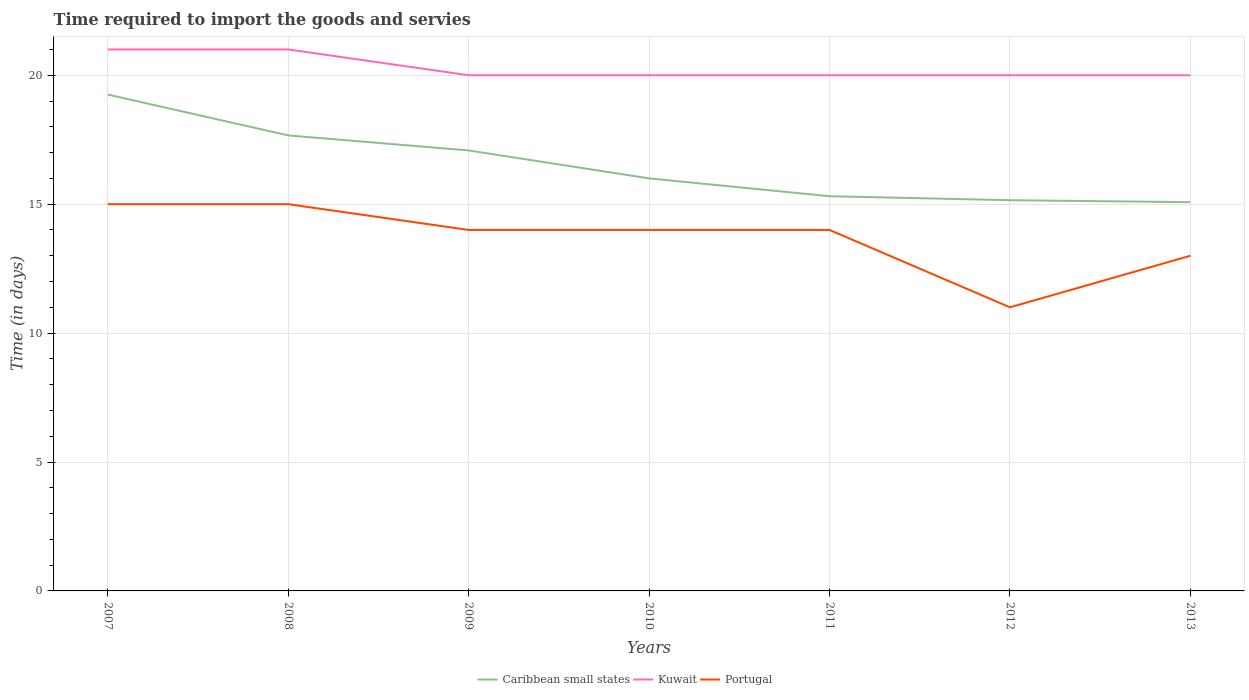How many different coloured lines are there?
Your answer should be very brief. 3. Does the line corresponding to Kuwait intersect with the line corresponding to Caribbean small states?
Offer a terse response. No. Is the number of lines equal to the number of legend labels?
Ensure brevity in your answer.  Yes. Across all years, what is the maximum number of days required to import the goods and services in Caribbean small states?
Ensure brevity in your answer.  15.08. What is the total number of days required to import the goods and services in Caribbean small states in the graph?
Provide a short and direct response. 4.17. What is the difference between the highest and the second highest number of days required to import the goods and services in Caribbean small states?
Give a very brief answer. 4.17. What is the difference between the highest and the lowest number of days required to import the goods and services in Portugal?
Your answer should be very brief. 5. How many lines are there?
Keep it short and to the point. 3. How many years are there in the graph?
Your answer should be compact. 7. Are the values on the major ticks of Y-axis written in scientific E-notation?
Provide a succinct answer. No. What is the title of the graph?
Your response must be concise. Time required to import the goods and servies. What is the label or title of the Y-axis?
Offer a very short reply. Time (in days). What is the Time (in days) in Caribbean small states in 2007?
Your answer should be very brief. 19.25. What is the Time (in days) of Portugal in 2007?
Offer a terse response. 15. What is the Time (in days) of Caribbean small states in 2008?
Offer a very short reply. 17.67. What is the Time (in days) in Kuwait in 2008?
Your response must be concise. 21. What is the Time (in days) in Portugal in 2008?
Give a very brief answer. 15. What is the Time (in days) in Caribbean small states in 2009?
Offer a terse response. 17.08. What is the Time (in days) in Kuwait in 2009?
Your response must be concise. 20. What is the Time (in days) of Kuwait in 2010?
Offer a terse response. 20. What is the Time (in days) of Portugal in 2010?
Keep it short and to the point. 14. What is the Time (in days) in Caribbean small states in 2011?
Keep it short and to the point. 15.31. What is the Time (in days) in Portugal in 2011?
Your answer should be very brief. 14. What is the Time (in days) in Caribbean small states in 2012?
Your answer should be compact. 15.15. What is the Time (in days) in Kuwait in 2012?
Your answer should be very brief. 20. What is the Time (in days) in Portugal in 2012?
Your answer should be very brief. 11. What is the Time (in days) of Caribbean small states in 2013?
Keep it short and to the point. 15.08. Across all years, what is the maximum Time (in days) of Caribbean small states?
Offer a very short reply. 19.25. Across all years, what is the maximum Time (in days) in Kuwait?
Your answer should be compact. 21. Across all years, what is the minimum Time (in days) in Caribbean small states?
Give a very brief answer. 15.08. Across all years, what is the minimum Time (in days) of Kuwait?
Offer a very short reply. 20. What is the total Time (in days) of Caribbean small states in the graph?
Offer a terse response. 115.54. What is the total Time (in days) in Kuwait in the graph?
Provide a succinct answer. 142. What is the total Time (in days) of Portugal in the graph?
Offer a terse response. 96. What is the difference between the Time (in days) in Caribbean small states in 2007 and that in 2008?
Make the answer very short. 1.58. What is the difference between the Time (in days) in Caribbean small states in 2007 and that in 2009?
Offer a very short reply. 2.17. What is the difference between the Time (in days) in Portugal in 2007 and that in 2009?
Offer a terse response. 1. What is the difference between the Time (in days) in Kuwait in 2007 and that in 2010?
Your answer should be very brief. 1. What is the difference between the Time (in days) in Portugal in 2007 and that in 2010?
Offer a very short reply. 1. What is the difference between the Time (in days) of Caribbean small states in 2007 and that in 2011?
Your answer should be very brief. 3.94. What is the difference between the Time (in days) of Kuwait in 2007 and that in 2011?
Your answer should be compact. 1. What is the difference between the Time (in days) in Caribbean small states in 2007 and that in 2012?
Give a very brief answer. 4.1. What is the difference between the Time (in days) of Kuwait in 2007 and that in 2012?
Your answer should be compact. 1. What is the difference between the Time (in days) in Portugal in 2007 and that in 2012?
Provide a succinct answer. 4. What is the difference between the Time (in days) in Caribbean small states in 2007 and that in 2013?
Give a very brief answer. 4.17. What is the difference between the Time (in days) of Portugal in 2007 and that in 2013?
Make the answer very short. 2. What is the difference between the Time (in days) of Caribbean small states in 2008 and that in 2009?
Keep it short and to the point. 0.58. What is the difference between the Time (in days) in Portugal in 2008 and that in 2009?
Offer a very short reply. 1. What is the difference between the Time (in days) in Caribbean small states in 2008 and that in 2010?
Your answer should be compact. 1.67. What is the difference between the Time (in days) of Caribbean small states in 2008 and that in 2011?
Keep it short and to the point. 2.36. What is the difference between the Time (in days) of Portugal in 2008 and that in 2011?
Provide a short and direct response. 1. What is the difference between the Time (in days) in Caribbean small states in 2008 and that in 2012?
Your answer should be compact. 2.51. What is the difference between the Time (in days) of Caribbean small states in 2008 and that in 2013?
Your response must be concise. 2.59. What is the difference between the Time (in days) of Kuwait in 2008 and that in 2013?
Offer a very short reply. 1. What is the difference between the Time (in days) in Portugal in 2008 and that in 2013?
Ensure brevity in your answer.  2. What is the difference between the Time (in days) in Kuwait in 2009 and that in 2010?
Give a very brief answer. 0. What is the difference between the Time (in days) of Portugal in 2009 and that in 2010?
Give a very brief answer. 0. What is the difference between the Time (in days) in Caribbean small states in 2009 and that in 2011?
Your response must be concise. 1.78. What is the difference between the Time (in days) of Caribbean small states in 2009 and that in 2012?
Your answer should be compact. 1.93. What is the difference between the Time (in days) in Kuwait in 2009 and that in 2012?
Provide a succinct answer. 0. What is the difference between the Time (in days) of Caribbean small states in 2009 and that in 2013?
Your answer should be very brief. 2.01. What is the difference between the Time (in days) in Kuwait in 2009 and that in 2013?
Provide a short and direct response. 0. What is the difference between the Time (in days) in Portugal in 2009 and that in 2013?
Offer a very short reply. 1. What is the difference between the Time (in days) in Caribbean small states in 2010 and that in 2011?
Make the answer very short. 0.69. What is the difference between the Time (in days) of Portugal in 2010 and that in 2011?
Offer a terse response. 0. What is the difference between the Time (in days) of Caribbean small states in 2010 and that in 2012?
Your answer should be compact. 0.85. What is the difference between the Time (in days) in Portugal in 2010 and that in 2012?
Keep it short and to the point. 3. What is the difference between the Time (in days) in Caribbean small states in 2010 and that in 2013?
Keep it short and to the point. 0.92. What is the difference between the Time (in days) in Kuwait in 2010 and that in 2013?
Keep it short and to the point. 0. What is the difference between the Time (in days) in Caribbean small states in 2011 and that in 2012?
Keep it short and to the point. 0.15. What is the difference between the Time (in days) in Kuwait in 2011 and that in 2012?
Your answer should be compact. 0. What is the difference between the Time (in days) in Portugal in 2011 and that in 2012?
Keep it short and to the point. 3. What is the difference between the Time (in days) in Caribbean small states in 2011 and that in 2013?
Your response must be concise. 0.23. What is the difference between the Time (in days) of Kuwait in 2011 and that in 2013?
Give a very brief answer. 0. What is the difference between the Time (in days) in Caribbean small states in 2012 and that in 2013?
Provide a succinct answer. 0.08. What is the difference between the Time (in days) of Kuwait in 2012 and that in 2013?
Keep it short and to the point. 0. What is the difference between the Time (in days) in Portugal in 2012 and that in 2013?
Provide a short and direct response. -2. What is the difference between the Time (in days) of Caribbean small states in 2007 and the Time (in days) of Kuwait in 2008?
Your answer should be compact. -1.75. What is the difference between the Time (in days) of Caribbean small states in 2007 and the Time (in days) of Portugal in 2008?
Provide a short and direct response. 4.25. What is the difference between the Time (in days) in Caribbean small states in 2007 and the Time (in days) in Kuwait in 2009?
Your answer should be compact. -0.75. What is the difference between the Time (in days) in Caribbean small states in 2007 and the Time (in days) in Portugal in 2009?
Give a very brief answer. 5.25. What is the difference between the Time (in days) of Kuwait in 2007 and the Time (in days) of Portugal in 2009?
Keep it short and to the point. 7. What is the difference between the Time (in days) in Caribbean small states in 2007 and the Time (in days) in Kuwait in 2010?
Provide a succinct answer. -0.75. What is the difference between the Time (in days) in Caribbean small states in 2007 and the Time (in days) in Portugal in 2010?
Provide a short and direct response. 5.25. What is the difference between the Time (in days) in Caribbean small states in 2007 and the Time (in days) in Kuwait in 2011?
Make the answer very short. -0.75. What is the difference between the Time (in days) of Caribbean small states in 2007 and the Time (in days) of Portugal in 2011?
Your answer should be compact. 5.25. What is the difference between the Time (in days) in Kuwait in 2007 and the Time (in days) in Portugal in 2011?
Your answer should be very brief. 7. What is the difference between the Time (in days) in Caribbean small states in 2007 and the Time (in days) in Kuwait in 2012?
Ensure brevity in your answer.  -0.75. What is the difference between the Time (in days) of Caribbean small states in 2007 and the Time (in days) of Portugal in 2012?
Offer a terse response. 8.25. What is the difference between the Time (in days) in Caribbean small states in 2007 and the Time (in days) in Kuwait in 2013?
Provide a succinct answer. -0.75. What is the difference between the Time (in days) in Caribbean small states in 2007 and the Time (in days) in Portugal in 2013?
Give a very brief answer. 6.25. What is the difference between the Time (in days) of Kuwait in 2007 and the Time (in days) of Portugal in 2013?
Ensure brevity in your answer.  8. What is the difference between the Time (in days) in Caribbean small states in 2008 and the Time (in days) in Kuwait in 2009?
Offer a terse response. -2.33. What is the difference between the Time (in days) of Caribbean small states in 2008 and the Time (in days) of Portugal in 2009?
Your answer should be very brief. 3.67. What is the difference between the Time (in days) of Kuwait in 2008 and the Time (in days) of Portugal in 2009?
Provide a succinct answer. 7. What is the difference between the Time (in days) of Caribbean small states in 2008 and the Time (in days) of Kuwait in 2010?
Ensure brevity in your answer.  -2.33. What is the difference between the Time (in days) in Caribbean small states in 2008 and the Time (in days) in Portugal in 2010?
Provide a short and direct response. 3.67. What is the difference between the Time (in days) of Caribbean small states in 2008 and the Time (in days) of Kuwait in 2011?
Provide a succinct answer. -2.33. What is the difference between the Time (in days) of Caribbean small states in 2008 and the Time (in days) of Portugal in 2011?
Offer a very short reply. 3.67. What is the difference between the Time (in days) of Kuwait in 2008 and the Time (in days) of Portugal in 2011?
Offer a terse response. 7. What is the difference between the Time (in days) in Caribbean small states in 2008 and the Time (in days) in Kuwait in 2012?
Offer a terse response. -2.33. What is the difference between the Time (in days) of Caribbean small states in 2008 and the Time (in days) of Kuwait in 2013?
Ensure brevity in your answer.  -2.33. What is the difference between the Time (in days) in Caribbean small states in 2008 and the Time (in days) in Portugal in 2013?
Offer a terse response. 4.67. What is the difference between the Time (in days) in Kuwait in 2008 and the Time (in days) in Portugal in 2013?
Offer a terse response. 8. What is the difference between the Time (in days) of Caribbean small states in 2009 and the Time (in days) of Kuwait in 2010?
Keep it short and to the point. -2.92. What is the difference between the Time (in days) of Caribbean small states in 2009 and the Time (in days) of Portugal in 2010?
Your answer should be compact. 3.08. What is the difference between the Time (in days) of Caribbean small states in 2009 and the Time (in days) of Kuwait in 2011?
Offer a very short reply. -2.92. What is the difference between the Time (in days) of Caribbean small states in 2009 and the Time (in days) of Portugal in 2011?
Provide a short and direct response. 3.08. What is the difference between the Time (in days) of Caribbean small states in 2009 and the Time (in days) of Kuwait in 2012?
Provide a succinct answer. -2.92. What is the difference between the Time (in days) in Caribbean small states in 2009 and the Time (in days) in Portugal in 2012?
Make the answer very short. 6.08. What is the difference between the Time (in days) of Caribbean small states in 2009 and the Time (in days) of Kuwait in 2013?
Offer a very short reply. -2.92. What is the difference between the Time (in days) in Caribbean small states in 2009 and the Time (in days) in Portugal in 2013?
Make the answer very short. 4.08. What is the difference between the Time (in days) of Caribbean small states in 2010 and the Time (in days) of Kuwait in 2012?
Provide a succinct answer. -4. What is the difference between the Time (in days) of Kuwait in 2010 and the Time (in days) of Portugal in 2012?
Your answer should be very brief. 9. What is the difference between the Time (in days) of Kuwait in 2010 and the Time (in days) of Portugal in 2013?
Give a very brief answer. 7. What is the difference between the Time (in days) of Caribbean small states in 2011 and the Time (in days) of Kuwait in 2012?
Offer a very short reply. -4.69. What is the difference between the Time (in days) in Caribbean small states in 2011 and the Time (in days) in Portugal in 2012?
Your answer should be very brief. 4.31. What is the difference between the Time (in days) of Kuwait in 2011 and the Time (in days) of Portugal in 2012?
Keep it short and to the point. 9. What is the difference between the Time (in days) in Caribbean small states in 2011 and the Time (in days) in Kuwait in 2013?
Ensure brevity in your answer.  -4.69. What is the difference between the Time (in days) of Caribbean small states in 2011 and the Time (in days) of Portugal in 2013?
Your answer should be compact. 2.31. What is the difference between the Time (in days) of Caribbean small states in 2012 and the Time (in days) of Kuwait in 2013?
Offer a very short reply. -4.85. What is the difference between the Time (in days) in Caribbean small states in 2012 and the Time (in days) in Portugal in 2013?
Your answer should be compact. 2.15. What is the difference between the Time (in days) of Kuwait in 2012 and the Time (in days) of Portugal in 2013?
Offer a terse response. 7. What is the average Time (in days) of Caribbean small states per year?
Your response must be concise. 16.51. What is the average Time (in days) in Kuwait per year?
Offer a very short reply. 20.29. What is the average Time (in days) in Portugal per year?
Your answer should be compact. 13.71. In the year 2007, what is the difference between the Time (in days) in Caribbean small states and Time (in days) in Kuwait?
Keep it short and to the point. -1.75. In the year 2007, what is the difference between the Time (in days) in Caribbean small states and Time (in days) in Portugal?
Provide a short and direct response. 4.25. In the year 2007, what is the difference between the Time (in days) of Kuwait and Time (in days) of Portugal?
Make the answer very short. 6. In the year 2008, what is the difference between the Time (in days) in Caribbean small states and Time (in days) in Portugal?
Offer a terse response. 2.67. In the year 2009, what is the difference between the Time (in days) of Caribbean small states and Time (in days) of Kuwait?
Your answer should be compact. -2.92. In the year 2009, what is the difference between the Time (in days) in Caribbean small states and Time (in days) in Portugal?
Ensure brevity in your answer.  3.08. In the year 2009, what is the difference between the Time (in days) of Kuwait and Time (in days) of Portugal?
Keep it short and to the point. 6. In the year 2010, what is the difference between the Time (in days) of Caribbean small states and Time (in days) of Kuwait?
Your answer should be very brief. -4. In the year 2010, what is the difference between the Time (in days) of Caribbean small states and Time (in days) of Portugal?
Your response must be concise. 2. In the year 2010, what is the difference between the Time (in days) of Kuwait and Time (in days) of Portugal?
Ensure brevity in your answer.  6. In the year 2011, what is the difference between the Time (in days) in Caribbean small states and Time (in days) in Kuwait?
Offer a very short reply. -4.69. In the year 2011, what is the difference between the Time (in days) of Caribbean small states and Time (in days) of Portugal?
Offer a terse response. 1.31. In the year 2012, what is the difference between the Time (in days) in Caribbean small states and Time (in days) in Kuwait?
Your answer should be very brief. -4.85. In the year 2012, what is the difference between the Time (in days) of Caribbean small states and Time (in days) of Portugal?
Ensure brevity in your answer.  4.15. In the year 2013, what is the difference between the Time (in days) of Caribbean small states and Time (in days) of Kuwait?
Offer a very short reply. -4.92. In the year 2013, what is the difference between the Time (in days) of Caribbean small states and Time (in days) of Portugal?
Your response must be concise. 2.08. In the year 2013, what is the difference between the Time (in days) of Kuwait and Time (in days) of Portugal?
Ensure brevity in your answer.  7. What is the ratio of the Time (in days) of Caribbean small states in 2007 to that in 2008?
Provide a succinct answer. 1.09. What is the ratio of the Time (in days) in Caribbean small states in 2007 to that in 2009?
Offer a very short reply. 1.13. What is the ratio of the Time (in days) of Portugal in 2007 to that in 2009?
Give a very brief answer. 1.07. What is the ratio of the Time (in days) in Caribbean small states in 2007 to that in 2010?
Make the answer very short. 1.2. What is the ratio of the Time (in days) in Kuwait in 2007 to that in 2010?
Your response must be concise. 1.05. What is the ratio of the Time (in days) in Portugal in 2007 to that in 2010?
Your response must be concise. 1.07. What is the ratio of the Time (in days) in Caribbean small states in 2007 to that in 2011?
Ensure brevity in your answer.  1.26. What is the ratio of the Time (in days) of Kuwait in 2007 to that in 2011?
Offer a terse response. 1.05. What is the ratio of the Time (in days) in Portugal in 2007 to that in 2011?
Your answer should be very brief. 1.07. What is the ratio of the Time (in days) of Caribbean small states in 2007 to that in 2012?
Your answer should be compact. 1.27. What is the ratio of the Time (in days) of Kuwait in 2007 to that in 2012?
Keep it short and to the point. 1.05. What is the ratio of the Time (in days) of Portugal in 2007 to that in 2012?
Give a very brief answer. 1.36. What is the ratio of the Time (in days) in Caribbean small states in 2007 to that in 2013?
Provide a short and direct response. 1.28. What is the ratio of the Time (in days) in Kuwait in 2007 to that in 2013?
Offer a terse response. 1.05. What is the ratio of the Time (in days) in Portugal in 2007 to that in 2013?
Your answer should be compact. 1.15. What is the ratio of the Time (in days) of Caribbean small states in 2008 to that in 2009?
Ensure brevity in your answer.  1.03. What is the ratio of the Time (in days) of Kuwait in 2008 to that in 2009?
Ensure brevity in your answer.  1.05. What is the ratio of the Time (in days) in Portugal in 2008 to that in 2009?
Make the answer very short. 1.07. What is the ratio of the Time (in days) in Caribbean small states in 2008 to that in 2010?
Your answer should be very brief. 1.1. What is the ratio of the Time (in days) in Kuwait in 2008 to that in 2010?
Provide a succinct answer. 1.05. What is the ratio of the Time (in days) of Portugal in 2008 to that in 2010?
Your answer should be very brief. 1.07. What is the ratio of the Time (in days) of Caribbean small states in 2008 to that in 2011?
Keep it short and to the point. 1.15. What is the ratio of the Time (in days) in Kuwait in 2008 to that in 2011?
Your response must be concise. 1.05. What is the ratio of the Time (in days) of Portugal in 2008 to that in 2011?
Keep it short and to the point. 1.07. What is the ratio of the Time (in days) in Caribbean small states in 2008 to that in 2012?
Your response must be concise. 1.17. What is the ratio of the Time (in days) of Kuwait in 2008 to that in 2012?
Make the answer very short. 1.05. What is the ratio of the Time (in days) of Portugal in 2008 to that in 2012?
Provide a short and direct response. 1.36. What is the ratio of the Time (in days) in Caribbean small states in 2008 to that in 2013?
Ensure brevity in your answer.  1.17. What is the ratio of the Time (in days) of Kuwait in 2008 to that in 2013?
Give a very brief answer. 1.05. What is the ratio of the Time (in days) in Portugal in 2008 to that in 2013?
Your answer should be very brief. 1.15. What is the ratio of the Time (in days) of Caribbean small states in 2009 to that in 2010?
Your answer should be compact. 1.07. What is the ratio of the Time (in days) of Kuwait in 2009 to that in 2010?
Your answer should be compact. 1. What is the ratio of the Time (in days) of Caribbean small states in 2009 to that in 2011?
Your answer should be very brief. 1.12. What is the ratio of the Time (in days) in Portugal in 2009 to that in 2011?
Your answer should be very brief. 1. What is the ratio of the Time (in days) of Caribbean small states in 2009 to that in 2012?
Your answer should be compact. 1.13. What is the ratio of the Time (in days) in Kuwait in 2009 to that in 2012?
Your answer should be compact. 1. What is the ratio of the Time (in days) of Portugal in 2009 to that in 2012?
Your answer should be compact. 1.27. What is the ratio of the Time (in days) in Caribbean small states in 2009 to that in 2013?
Offer a very short reply. 1.13. What is the ratio of the Time (in days) of Kuwait in 2009 to that in 2013?
Your response must be concise. 1. What is the ratio of the Time (in days) in Portugal in 2009 to that in 2013?
Offer a very short reply. 1.08. What is the ratio of the Time (in days) in Caribbean small states in 2010 to that in 2011?
Your answer should be very brief. 1.05. What is the ratio of the Time (in days) in Portugal in 2010 to that in 2011?
Make the answer very short. 1. What is the ratio of the Time (in days) of Caribbean small states in 2010 to that in 2012?
Offer a terse response. 1.06. What is the ratio of the Time (in days) of Kuwait in 2010 to that in 2012?
Make the answer very short. 1. What is the ratio of the Time (in days) in Portugal in 2010 to that in 2012?
Keep it short and to the point. 1.27. What is the ratio of the Time (in days) of Caribbean small states in 2010 to that in 2013?
Ensure brevity in your answer.  1.06. What is the ratio of the Time (in days) of Portugal in 2010 to that in 2013?
Offer a terse response. 1.08. What is the ratio of the Time (in days) of Caribbean small states in 2011 to that in 2012?
Provide a succinct answer. 1.01. What is the ratio of the Time (in days) in Portugal in 2011 to that in 2012?
Make the answer very short. 1.27. What is the ratio of the Time (in days) in Caribbean small states in 2011 to that in 2013?
Your answer should be very brief. 1.02. What is the ratio of the Time (in days) of Kuwait in 2011 to that in 2013?
Your answer should be very brief. 1. What is the ratio of the Time (in days) in Portugal in 2011 to that in 2013?
Make the answer very short. 1.08. What is the ratio of the Time (in days) of Portugal in 2012 to that in 2013?
Provide a succinct answer. 0.85. What is the difference between the highest and the second highest Time (in days) in Caribbean small states?
Provide a succinct answer. 1.58. What is the difference between the highest and the lowest Time (in days) in Caribbean small states?
Ensure brevity in your answer.  4.17. What is the difference between the highest and the lowest Time (in days) in Kuwait?
Keep it short and to the point. 1. What is the difference between the highest and the lowest Time (in days) in Portugal?
Provide a succinct answer. 4. 